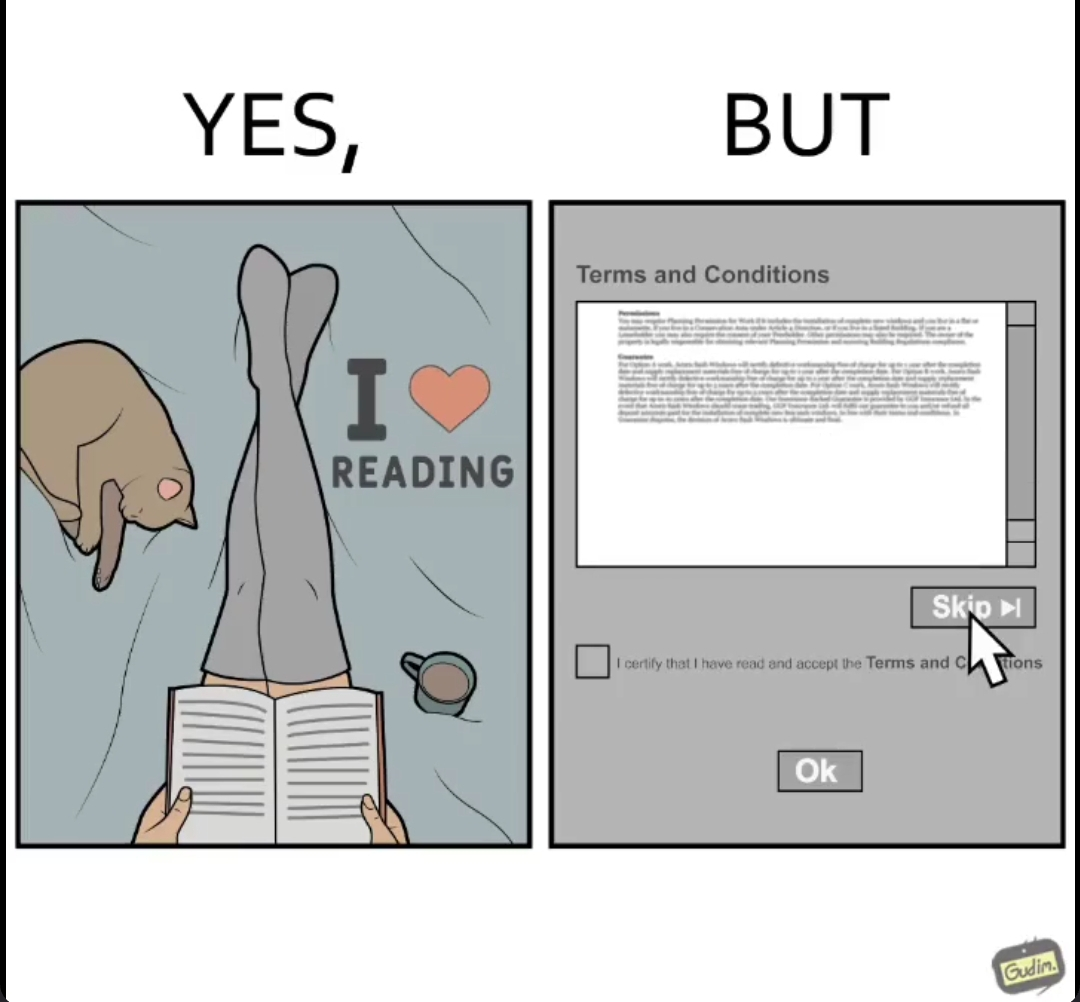Describe the contrast between the left and right parts of this image. In the left part of the image: a person reading a book on a bed sitting next to a cat and some coffee In the right part of the image: a person trying to skip reading the terms and conditions on the internet 